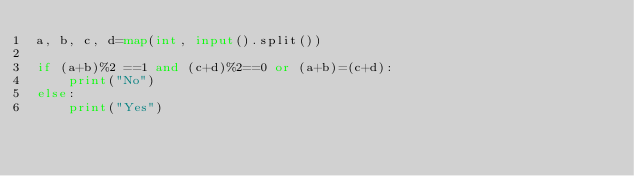<code> <loc_0><loc_0><loc_500><loc_500><_Python_>a, b, c, d=map(int, input().split())

if (a+b)%2 ==1 and (c+d)%2==0 or (a+b)=(c+d):
    print("No")
else:
    print("Yes")
</code> 